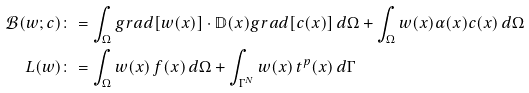<formula> <loc_0><loc_0><loc_500><loc_500>\mathcal { B } ( w ; c ) & \colon = \int _ { \Omega } g r a d [ w ( x ) ] \cdot \mathbb { D } ( x ) g r a d [ c ( x ) ] \, d \Omega + \int _ { \Omega } w ( x ) \alpha ( x ) c ( x ) \, d \Omega \\ L ( w ) & \colon = \int _ { \Omega } w ( x ) \, f ( x ) \, d \Omega + \int _ { \Gamma ^ { N } } w ( x ) \, t ^ { p } ( x ) \, d \Gamma</formula> 